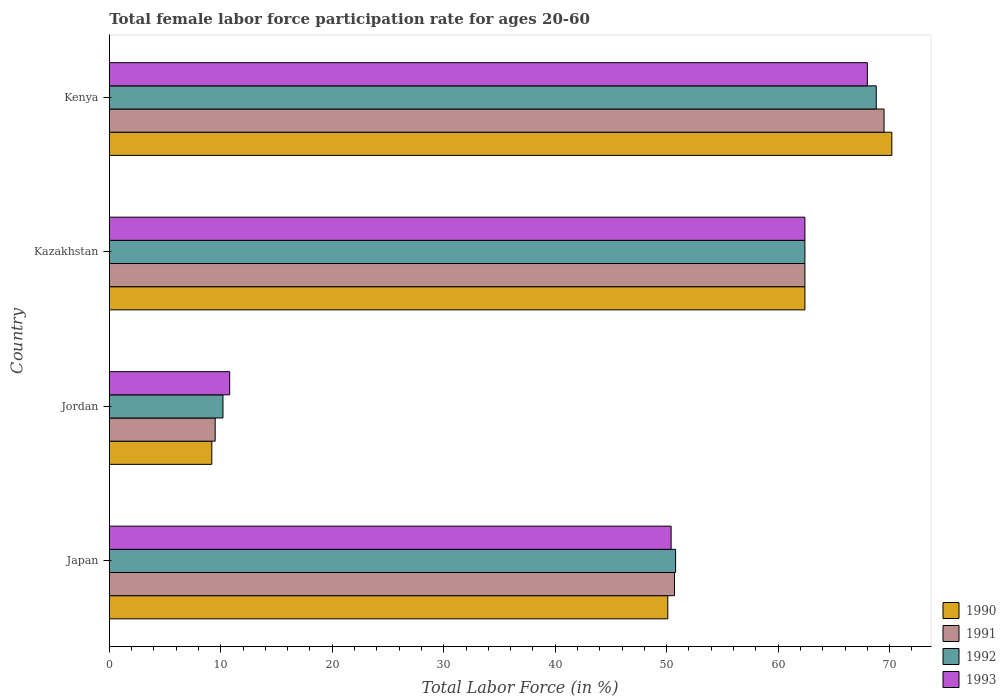How many groups of bars are there?
Your answer should be very brief. 4. How many bars are there on the 3rd tick from the top?
Provide a succinct answer. 4. What is the label of the 1st group of bars from the top?
Make the answer very short. Kenya. What is the female labor force participation rate in 1991 in Japan?
Offer a very short reply. 50.7. In which country was the female labor force participation rate in 1990 maximum?
Your answer should be compact. Kenya. In which country was the female labor force participation rate in 1993 minimum?
Your answer should be very brief. Jordan. What is the total female labor force participation rate in 1990 in the graph?
Provide a succinct answer. 191.9. What is the difference between the female labor force participation rate in 1993 in Japan and that in Jordan?
Your answer should be very brief. 39.6. What is the difference between the female labor force participation rate in 1992 in Jordan and the female labor force participation rate in 1993 in Kazakhstan?
Provide a short and direct response. -52.2. What is the average female labor force participation rate in 1991 per country?
Ensure brevity in your answer.  48.03. What is the difference between the female labor force participation rate in 1993 and female labor force participation rate in 1990 in Jordan?
Provide a succinct answer. 1.6. In how many countries, is the female labor force participation rate in 1993 greater than 52 %?
Make the answer very short. 2. What is the ratio of the female labor force participation rate in 1991 in Japan to that in Jordan?
Provide a succinct answer. 5.34. Is the female labor force participation rate in 1992 in Japan less than that in Kenya?
Offer a terse response. Yes. What is the difference between the highest and the second highest female labor force participation rate in 1992?
Offer a very short reply. 6.4. In how many countries, is the female labor force participation rate in 1990 greater than the average female labor force participation rate in 1990 taken over all countries?
Your response must be concise. 3. Is it the case that in every country, the sum of the female labor force participation rate in 1992 and female labor force participation rate in 1993 is greater than the sum of female labor force participation rate in 1991 and female labor force participation rate in 1990?
Keep it short and to the point. No. Are all the bars in the graph horizontal?
Give a very brief answer. Yes. How many countries are there in the graph?
Ensure brevity in your answer.  4. Does the graph contain any zero values?
Keep it short and to the point. No. Where does the legend appear in the graph?
Offer a very short reply. Bottom right. What is the title of the graph?
Give a very brief answer. Total female labor force participation rate for ages 20-60. What is the Total Labor Force (in %) in 1990 in Japan?
Provide a succinct answer. 50.1. What is the Total Labor Force (in %) in 1991 in Japan?
Offer a very short reply. 50.7. What is the Total Labor Force (in %) of 1992 in Japan?
Your answer should be very brief. 50.8. What is the Total Labor Force (in %) in 1993 in Japan?
Keep it short and to the point. 50.4. What is the Total Labor Force (in %) of 1990 in Jordan?
Your response must be concise. 9.2. What is the Total Labor Force (in %) of 1992 in Jordan?
Offer a terse response. 10.2. What is the Total Labor Force (in %) in 1993 in Jordan?
Ensure brevity in your answer.  10.8. What is the Total Labor Force (in %) of 1990 in Kazakhstan?
Offer a very short reply. 62.4. What is the Total Labor Force (in %) of 1991 in Kazakhstan?
Your answer should be very brief. 62.4. What is the Total Labor Force (in %) in 1992 in Kazakhstan?
Offer a terse response. 62.4. What is the Total Labor Force (in %) of 1993 in Kazakhstan?
Offer a very short reply. 62.4. What is the Total Labor Force (in %) in 1990 in Kenya?
Provide a succinct answer. 70.2. What is the Total Labor Force (in %) of 1991 in Kenya?
Ensure brevity in your answer.  69.5. What is the Total Labor Force (in %) of 1992 in Kenya?
Provide a short and direct response. 68.8. Across all countries, what is the maximum Total Labor Force (in %) in 1990?
Provide a succinct answer. 70.2. Across all countries, what is the maximum Total Labor Force (in %) in 1991?
Your answer should be compact. 69.5. Across all countries, what is the maximum Total Labor Force (in %) in 1992?
Make the answer very short. 68.8. Across all countries, what is the minimum Total Labor Force (in %) in 1990?
Offer a terse response. 9.2. Across all countries, what is the minimum Total Labor Force (in %) in 1992?
Keep it short and to the point. 10.2. Across all countries, what is the minimum Total Labor Force (in %) of 1993?
Ensure brevity in your answer.  10.8. What is the total Total Labor Force (in %) of 1990 in the graph?
Your answer should be very brief. 191.9. What is the total Total Labor Force (in %) in 1991 in the graph?
Offer a terse response. 192.1. What is the total Total Labor Force (in %) in 1992 in the graph?
Your answer should be very brief. 192.2. What is the total Total Labor Force (in %) in 1993 in the graph?
Your answer should be very brief. 191.6. What is the difference between the Total Labor Force (in %) in 1990 in Japan and that in Jordan?
Make the answer very short. 40.9. What is the difference between the Total Labor Force (in %) in 1991 in Japan and that in Jordan?
Give a very brief answer. 41.2. What is the difference between the Total Labor Force (in %) of 1992 in Japan and that in Jordan?
Offer a terse response. 40.6. What is the difference between the Total Labor Force (in %) in 1993 in Japan and that in Jordan?
Provide a short and direct response. 39.6. What is the difference between the Total Labor Force (in %) in 1990 in Japan and that in Kazakhstan?
Offer a very short reply. -12.3. What is the difference between the Total Labor Force (in %) of 1991 in Japan and that in Kazakhstan?
Provide a short and direct response. -11.7. What is the difference between the Total Labor Force (in %) in 1992 in Japan and that in Kazakhstan?
Your answer should be very brief. -11.6. What is the difference between the Total Labor Force (in %) of 1990 in Japan and that in Kenya?
Provide a short and direct response. -20.1. What is the difference between the Total Labor Force (in %) in 1991 in Japan and that in Kenya?
Your answer should be very brief. -18.8. What is the difference between the Total Labor Force (in %) of 1992 in Japan and that in Kenya?
Your answer should be compact. -18. What is the difference between the Total Labor Force (in %) of 1993 in Japan and that in Kenya?
Ensure brevity in your answer.  -17.6. What is the difference between the Total Labor Force (in %) of 1990 in Jordan and that in Kazakhstan?
Give a very brief answer. -53.2. What is the difference between the Total Labor Force (in %) of 1991 in Jordan and that in Kazakhstan?
Your response must be concise. -52.9. What is the difference between the Total Labor Force (in %) of 1992 in Jordan and that in Kazakhstan?
Ensure brevity in your answer.  -52.2. What is the difference between the Total Labor Force (in %) of 1993 in Jordan and that in Kazakhstan?
Make the answer very short. -51.6. What is the difference between the Total Labor Force (in %) in 1990 in Jordan and that in Kenya?
Make the answer very short. -61. What is the difference between the Total Labor Force (in %) of 1991 in Jordan and that in Kenya?
Give a very brief answer. -60. What is the difference between the Total Labor Force (in %) in 1992 in Jordan and that in Kenya?
Your answer should be compact. -58.6. What is the difference between the Total Labor Force (in %) in 1993 in Jordan and that in Kenya?
Offer a terse response. -57.2. What is the difference between the Total Labor Force (in %) in 1990 in Kazakhstan and that in Kenya?
Make the answer very short. -7.8. What is the difference between the Total Labor Force (in %) of 1992 in Kazakhstan and that in Kenya?
Ensure brevity in your answer.  -6.4. What is the difference between the Total Labor Force (in %) in 1993 in Kazakhstan and that in Kenya?
Ensure brevity in your answer.  -5.6. What is the difference between the Total Labor Force (in %) of 1990 in Japan and the Total Labor Force (in %) of 1991 in Jordan?
Ensure brevity in your answer.  40.6. What is the difference between the Total Labor Force (in %) in 1990 in Japan and the Total Labor Force (in %) in 1992 in Jordan?
Provide a short and direct response. 39.9. What is the difference between the Total Labor Force (in %) in 1990 in Japan and the Total Labor Force (in %) in 1993 in Jordan?
Offer a terse response. 39.3. What is the difference between the Total Labor Force (in %) of 1991 in Japan and the Total Labor Force (in %) of 1992 in Jordan?
Keep it short and to the point. 40.5. What is the difference between the Total Labor Force (in %) of 1991 in Japan and the Total Labor Force (in %) of 1993 in Jordan?
Ensure brevity in your answer.  39.9. What is the difference between the Total Labor Force (in %) in 1990 in Japan and the Total Labor Force (in %) in 1991 in Kazakhstan?
Make the answer very short. -12.3. What is the difference between the Total Labor Force (in %) in 1990 in Japan and the Total Labor Force (in %) in 1992 in Kazakhstan?
Give a very brief answer. -12.3. What is the difference between the Total Labor Force (in %) in 1991 in Japan and the Total Labor Force (in %) in 1993 in Kazakhstan?
Provide a short and direct response. -11.7. What is the difference between the Total Labor Force (in %) in 1990 in Japan and the Total Labor Force (in %) in 1991 in Kenya?
Give a very brief answer. -19.4. What is the difference between the Total Labor Force (in %) in 1990 in Japan and the Total Labor Force (in %) in 1992 in Kenya?
Ensure brevity in your answer.  -18.7. What is the difference between the Total Labor Force (in %) in 1990 in Japan and the Total Labor Force (in %) in 1993 in Kenya?
Keep it short and to the point. -17.9. What is the difference between the Total Labor Force (in %) in 1991 in Japan and the Total Labor Force (in %) in 1992 in Kenya?
Ensure brevity in your answer.  -18.1. What is the difference between the Total Labor Force (in %) in 1991 in Japan and the Total Labor Force (in %) in 1993 in Kenya?
Offer a very short reply. -17.3. What is the difference between the Total Labor Force (in %) of 1992 in Japan and the Total Labor Force (in %) of 1993 in Kenya?
Make the answer very short. -17.2. What is the difference between the Total Labor Force (in %) in 1990 in Jordan and the Total Labor Force (in %) in 1991 in Kazakhstan?
Your answer should be very brief. -53.2. What is the difference between the Total Labor Force (in %) in 1990 in Jordan and the Total Labor Force (in %) in 1992 in Kazakhstan?
Your answer should be compact. -53.2. What is the difference between the Total Labor Force (in %) of 1990 in Jordan and the Total Labor Force (in %) of 1993 in Kazakhstan?
Your answer should be very brief. -53.2. What is the difference between the Total Labor Force (in %) in 1991 in Jordan and the Total Labor Force (in %) in 1992 in Kazakhstan?
Your answer should be compact. -52.9. What is the difference between the Total Labor Force (in %) in 1991 in Jordan and the Total Labor Force (in %) in 1993 in Kazakhstan?
Provide a short and direct response. -52.9. What is the difference between the Total Labor Force (in %) of 1992 in Jordan and the Total Labor Force (in %) of 1993 in Kazakhstan?
Provide a succinct answer. -52.2. What is the difference between the Total Labor Force (in %) of 1990 in Jordan and the Total Labor Force (in %) of 1991 in Kenya?
Provide a short and direct response. -60.3. What is the difference between the Total Labor Force (in %) of 1990 in Jordan and the Total Labor Force (in %) of 1992 in Kenya?
Offer a terse response. -59.6. What is the difference between the Total Labor Force (in %) of 1990 in Jordan and the Total Labor Force (in %) of 1993 in Kenya?
Provide a succinct answer. -58.8. What is the difference between the Total Labor Force (in %) in 1991 in Jordan and the Total Labor Force (in %) in 1992 in Kenya?
Give a very brief answer. -59.3. What is the difference between the Total Labor Force (in %) in 1991 in Jordan and the Total Labor Force (in %) in 1993 in Kenya?
Offer a terse response. -58.5. What is the difference between the Total Labor Force (in %) of 1992 in Jordan and the Total Labor Force (in %) of 1993 in Kenya?
Your answer should be compact. -57.8. What is the difference between the Total Labor Force (in %) in 1990 in Kazakhstan and the Total Labor Force (in %) in 1991 in Kenya?
Provide a short and direct response. -7.1. What is the difference between the Total Labor Force (in %) of 1991 in Kazakhstan and the Total Labor Force (in %) of 1992 in Kenya?
Your answer should be very brief. -6.4. What is the difference between the Total Labor Force (in %) in 1991 in Kazakhstan and the Total Labor Force (in %) in 1993 in Kenya?
Provide a succinct answer. -5.6. What is the difference between the Total Labor Force (in %) in 1992 in Kazakhstan and the Total Labor Force (in %) in 1993 in Kenya?
Your response must be concise. -5.6. What is the average Total Labor Force (in %) in 1990 per country?
Your answer should be very brief. 47.98. What is the average Total Labor Force (in %) in 1991 per country?
Provide a succinct answer. 48.02. What is the average Total Labor Force (in %) in 1992 per country?
Provide a succinct answer. 48.05. What is the average Total Labor Force (in %) in 1993 per country?
Your response must be concise. 47.9. What is the difference between the Total Labor Force (in %) of 1990 and Total Labor Force (in %) of 1993 in Japan?
Offer a very short reply. -0.3. What is the difference between the Total Labor Force (in %) of 1991 and Total Labor Force (in %) of 1992 in Japan?
Give a very brief answer. -0.1. What is the difference between the Total Labor Force (in %) of 1992 and Total Labor Force (in %) of 1993 in Japan?
Offer a very short reply. 0.4. What is the difference between the Total Labor Force (in %) of 1990 and Total Labor Force (in %) of 1991 in Jordan?
Your response must be concise. -0.3. What is the difference between the Total Labor Force (in %) in 1990 and Total Labor Force (in %) in 1993 in Jordan?
Your answer should be very brief. -1.6. What is the difference between the Total Labor Force (in %) in 1990 and Total Labor Force (in %) in 1992 in Kazakhstan?
Keep it short and to the point. 0. What is the difference between the Total Labor Force (in %) of 1992 and Total Labor Force (in %) of 1993 in Kazakhstan?
Make the answer very short. 0. What is the difference between the Total Labor Force (in %) of 1991 and Total Labor Force (in %) of 1992 in Kenya?
Provide a short and direct response. 0.7. What is the difference between the Total Labor Force (in %) of 1991 and Total Labor Force (in %) of 1993 in Kenya?
Your answer should be very brief. 1.5. What is the difference between the Total Labor Force (in %) in 1992 and Total Labor Force (in %) in 1993 in Kenya?
Your answer should be very brief. 0.8. What is the ratio of the Total Labor Force (in %) in 1990 in Japan to that in Jordan?
Your answer should be compact. 5.45. What is the ratio of the Total Labor Force (in %) in 1991 in Japan to that in Jordan?
Offer a terse response. 5.34. What is the ratio of the Total Labor Force (in %) in 1992 in Japan to that in Jordan?
Your answer should be very brief. 4.98. What is the ratio of the Total Labor Force (in %) in 1993 in Japan to that in Jordan?
Provide a succinct answer. 4.67. What is the ratio of the Total Labor Force (in %) in 1990 in Japan to that in Kazakhstan?
Your answer should be compact. 0.8. What is the ratio of the Total Labor Force (in %) of 1991 in Japan to that in Kazakhstan?
Your answer should be compact. 0.81. What is the ratio of the Total Labor Force (in %) of 1992 in Japan to that in Kazakhstan?
Ensure brevity in your answer.  0.81. What is the ratio of the Total Labor Force (in %) of 1993 in Japan to that in Kazakhstan?
Make the answer very short. 0.81. What is the ratio of the Total Labor Force (in %) in 1990 in Japan to that in Kenya?
Offer a terse response. 0.71. What is the ratio of the Total Labor Force (in %) of 1991 in Japan to that in Kenya?
Provide a short and direct response. 0.73. What is the ratio of the Total Labor Force (in %) of 1992 in Japan to that in Kenya?
Your answer should be compact. 0.74. What is the ratio of the Total Labor Force (in %) in 1993 in Japan to that in Kenya?
Ensure brevity in your answer.  0.74. What is the ratio of the Total Labor Force (in %) of 1990 in Jordan to that in Kazakhstan?
Give a very brief answer. 0.15. What is the ratio of the Total Labor Force (in %) of 1991 in Jordan to that in Kazakhstan?
Your answer should be very brief. 0.15. What is the ratio of the Total Labor Force (in %) of 1992 in Jordan to that in Kazakhstan?
Your answer should be compact. 0.16. What is the ratio of the Total Labor Force (in %) in 1993 in Jordan to that in Kazakhstan?
Make the answer very short. 0.17. What is the ratio of the Total Labor Force (in %) of 1990 in Jordan to that in Kenya?
Make the answer very short. 0.13. What is the ratio of the Total Labor Force (in %) of 1991 in Jordan to that in Kenya?
Offer a terse response. 0.14. What is the ratio of the Total Labor Force (in %) in 1992 in Jordan to that in Kenya?
Your answer should be compact. 0.15. What is the ratio of the Total Labor Force (in %) in 1993 in Jordan to that in Kenya?
Give a very brief answer. 0.16. What is the ratio of the Total Labor Force (in %) of 1990 in Kazakhstan to that in Kenya?
Your answer should be very brief. 0.89. What is the ratio of the Total Labor Force (in %) in 1991 in Kazakhstan to that in Kenya?
Your response must be concise. 0.9. What is the ratio of the Total Labor Force (in %) of 1992 in Kazakhstan to that in Kenya?
Your response must be concise. 0.91. What is the ratio of the Total Labor Force (in %) in 1993 in Kazakhstan to that in Kenya?
Keep it short and to the point. 0.92. What is the difference between the highest and the second highest Total Labor Force (in %) of 1993?
Provide a succinct answer. 5.6. What is the difference between the highest and the lowest Total Labor Force (in %) of 1990?
Keep it short and to the point. 61. What is the difference between the highest and the lowest Total Labor Force (in %) in 1992?
Offer a very short reply. 58.6. What is the difference between the highest and the lowest Total Labor Force (in %) in 1993?
Give a very brief answer. 57.2. 